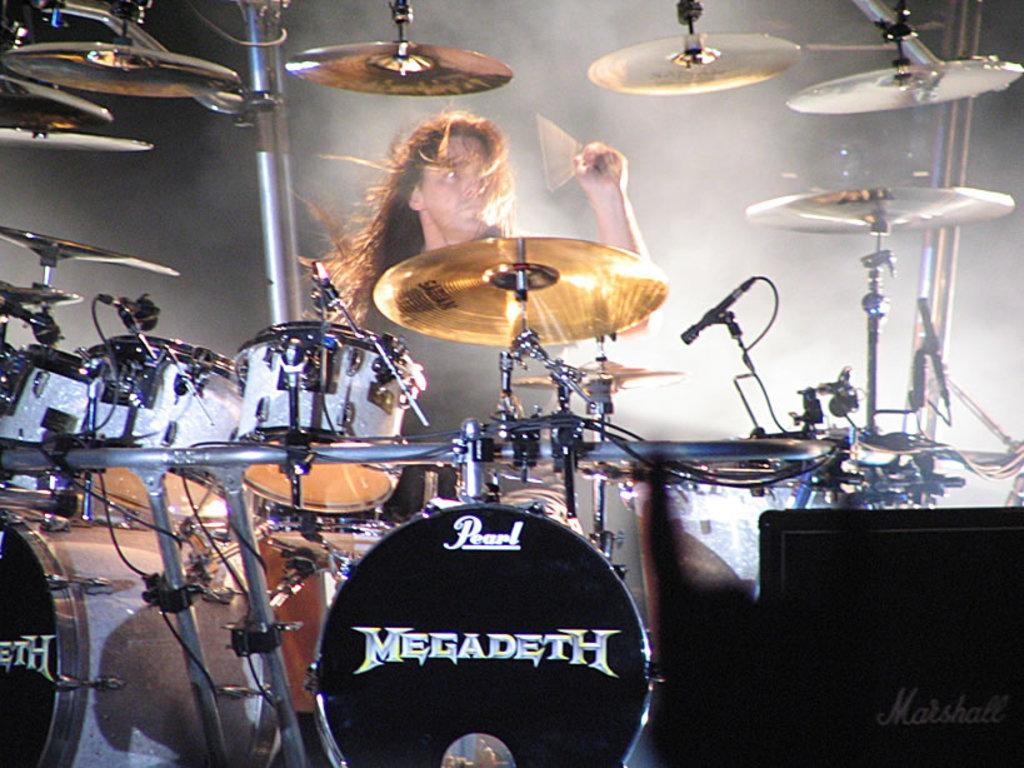What is the main subject of the image? There is a human in the image. What is the human doing in the image? The human is playing drums. How is the human playing the drums? The human is using sticks to play the drums. What else can be seen in the image? There is smoke visible in the image, and there is text on the drums. What type of religious ceremony is the human participating in, as depicted in the image? There is no indication of a religious ceremony in the image; it simply shows a human playing drums. Who is the manager of the human playing drums in the image? There is no manager mentioned or depicted in the image. 